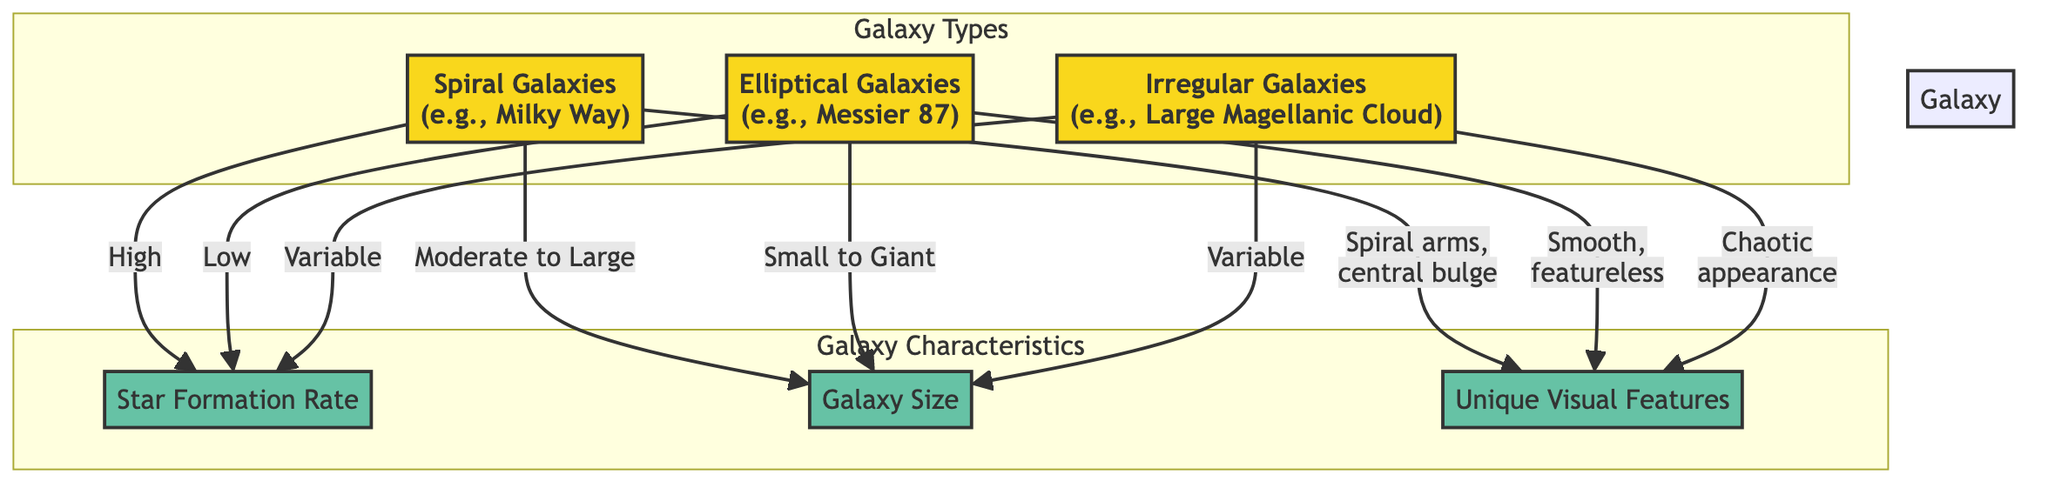What is the star formation rate for spiral galaxies? The diagram indicates that the star formation rate for spiral galaxies is categorized as "High." This is directly noted in the flow from the spiral galaxies to the star formation rate node.
Answer: High How many types of galaxies are shown in the diagram? The diagram presents three types of galaxies: spiral, elliptical, and irregular. By counting the nodes labeled with galaxy types, we confirm there are three.
Answer: 3 What is the size category of elliptical galaxies? According to the diagram, elliptical galaxies are described as having a size that ranges from "Small to Giant." This information is linked directly from the elliptical galaxies node to the galaxy size node.
Answer: Small to Giant Which type of galaxy has a chaotic appearance? The irregular galaxies are noted to have a "Chaotic appearance," which is specified in the visual features section connected to that galaxy type.
Answer: Irregular Galaxies What is the relationship between spiral galaxies and their visual features? The diagram shows that spiral galaxies have "Spiral arms, central bulge" as their unique visual features. This is a direct connection indicated in the visual features section for spiral galaxies.
Answer: Spiral arms, central bulge What defines the star formation rate for irregular galaxies? The star formation rate for irregular galaxies is described as "Variable." This is noted in the flow from the irregular galaxies node to the star formation rate node, indicating uncertainty in their rate.
Answer: Variable Which galaxy type has the lowest star formation rate? Elliptical galaxies have the lowest star formation rate as indicated by the "Low" label in their connection to the star formation rate node. This is directly stated in the diagram’s flow.
Answer: Low In terms of galaxy size, what category do spiral galaxies fall into? Spiral galaxies are categorized as having a size that is "Moderate to Large." This relationship is indicated in the diagram through the connection to the galaxy size node.
Answer: Moderate to Large What type of galaxy is exemplified by the Large Magellanic Cloud? The Large Magellanic Cloud is an example of an "Irregular Galaxy," as stated in the diagram where it connects to the irregular galaxies node.
Answer: Irregular Galaxy 